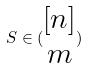<formula> <loc_0><loc_0><loc_500><loc_500>S \in ( \begin{matrix} [ n ] \\ m \end{matrix} )</formula> 